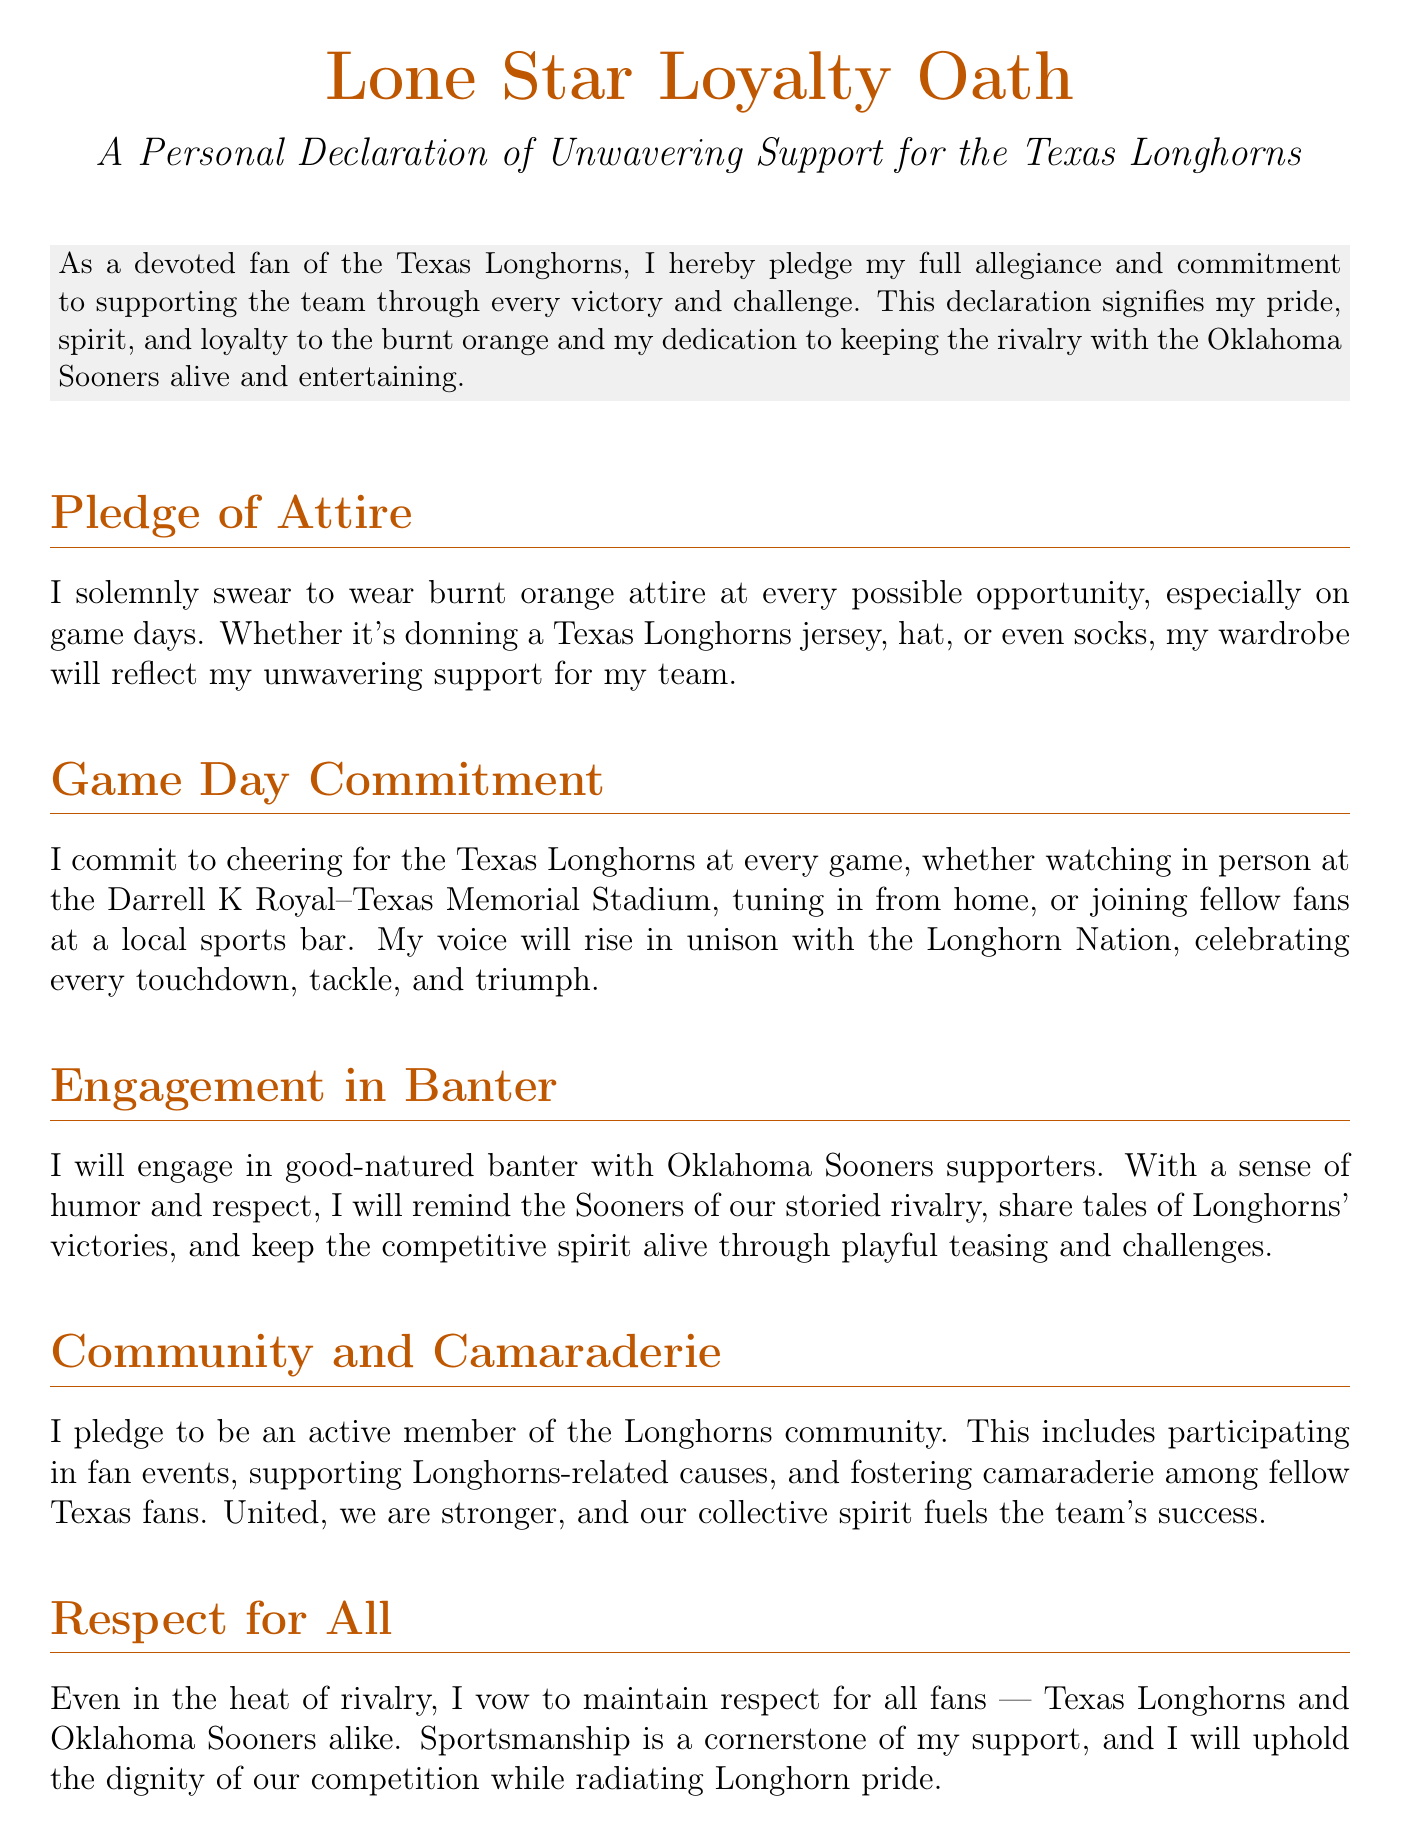What is the title of the document? The title is prominently displayed at the top of the document in large text.
Answer: Lone Star Loyalty Oath What color represents the Texas Longhorns in the document? The document mentions and prominently features the color associated with the Texas Longhorns.
Answer: Burnt orange How often does the pledge mention game days? The document emphasizes a specific occasion linked to showing support for the team.
Answer: Every possible opportunity What community aspect is pledged in the document? The document includes a section on involvement with fellow fans and events, showing team spirit.
Answer: Community and camaraderie What phrase completes the declaration? The closing line expresses the fan's enthusiastic support for the team.
Answer: Hook 'em Horns! How does the declaration address rival fans? The document outlines how the signatory plans to interact with supporters of a rival team.
Answer: Good-natured banter What is required to validate the pledge? The document concludes with a formal requirement to affirm the commitment contained within.
Answer: Signature What date is mentioned in the document? The document includes a section for noting a significant day for the declaration.
Answer: Date: What is the main commitment of the signatory during games? The document explains the key action that the signatory promises to take while supporting the team.
Answer: Cheering for the Texas Longhorns 